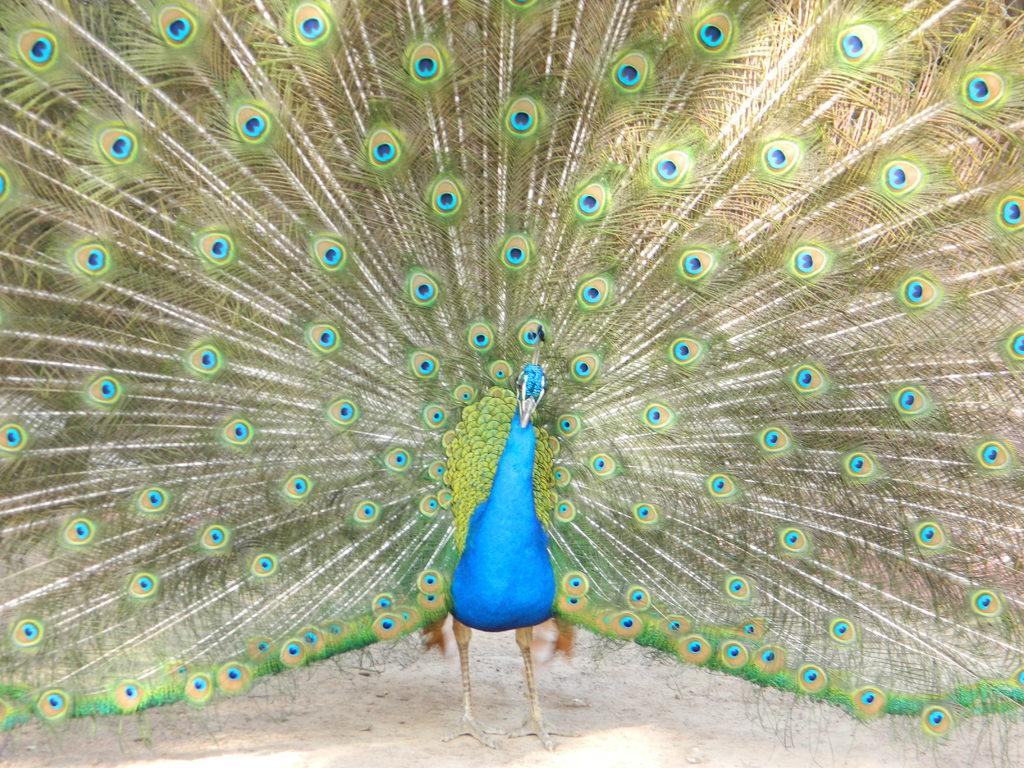What type of animal is in the image? There is a peacock in the image. Where is the peacock located in the image? The peacock is on the ground. What type of knife is the peacock using in the image? There is no knife present in the image; the peacock is not using any tools or objects. 